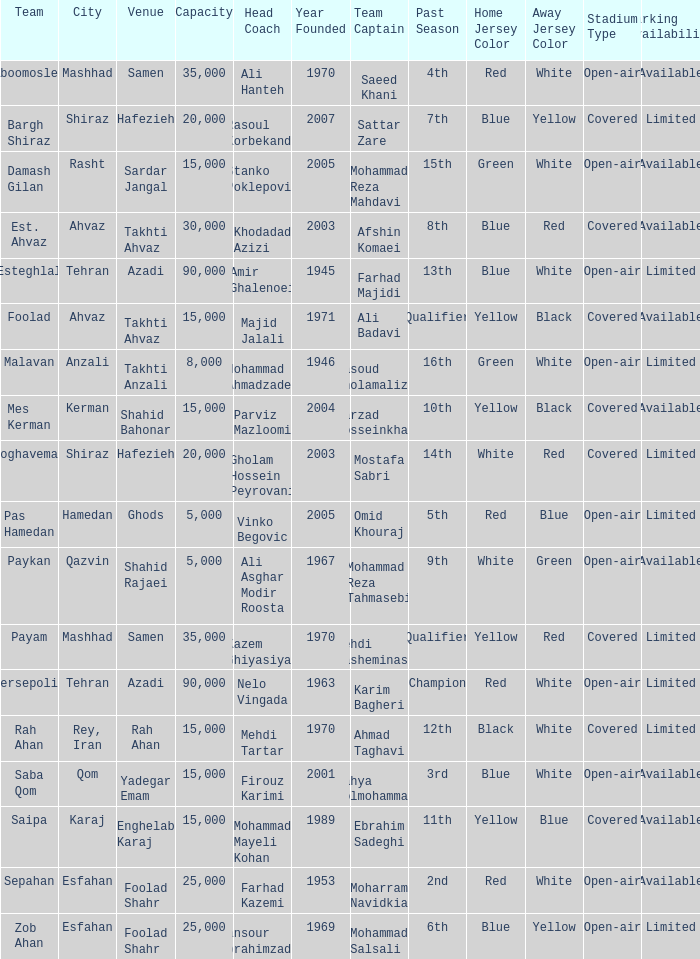What is the Capacity of the Venue of Head Coach Ali Asghar Modir Roosta? 5000.0. 